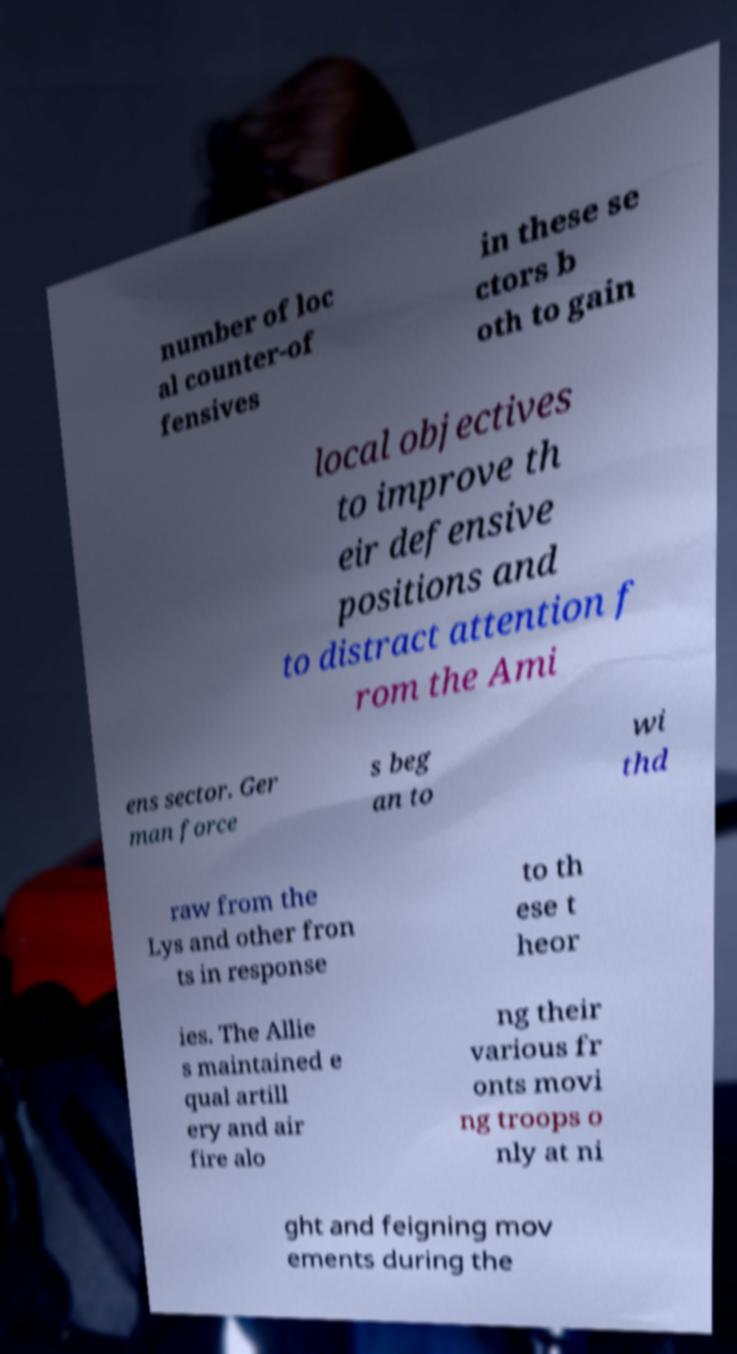There's text embedded in this image that I need extracted. Can you transcribe it verbatim? number of loc al counter-of fensives in these se ctors b oth to gain local objectives to improve th eir defensive positions and to distract attention f rom the Ami ens sector. Ger man force s beg an to wi thd raw from the Lys and other fron ts in response to th ese t heor ies. The Allie s maintained e qual artill ery and air fire alo ng their various fr onts movi ng troops o nly at ni ght and feigning mov ements during the 